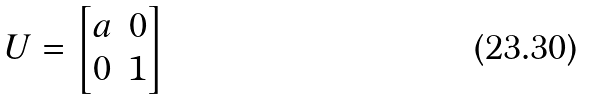Convert formula to latex. <formula><loc_0><loc_0><loc_500><loc_500>U = \begin{bmatrix} a & 0 \\ 0 & 1 \end{bmatrix}</formula> 